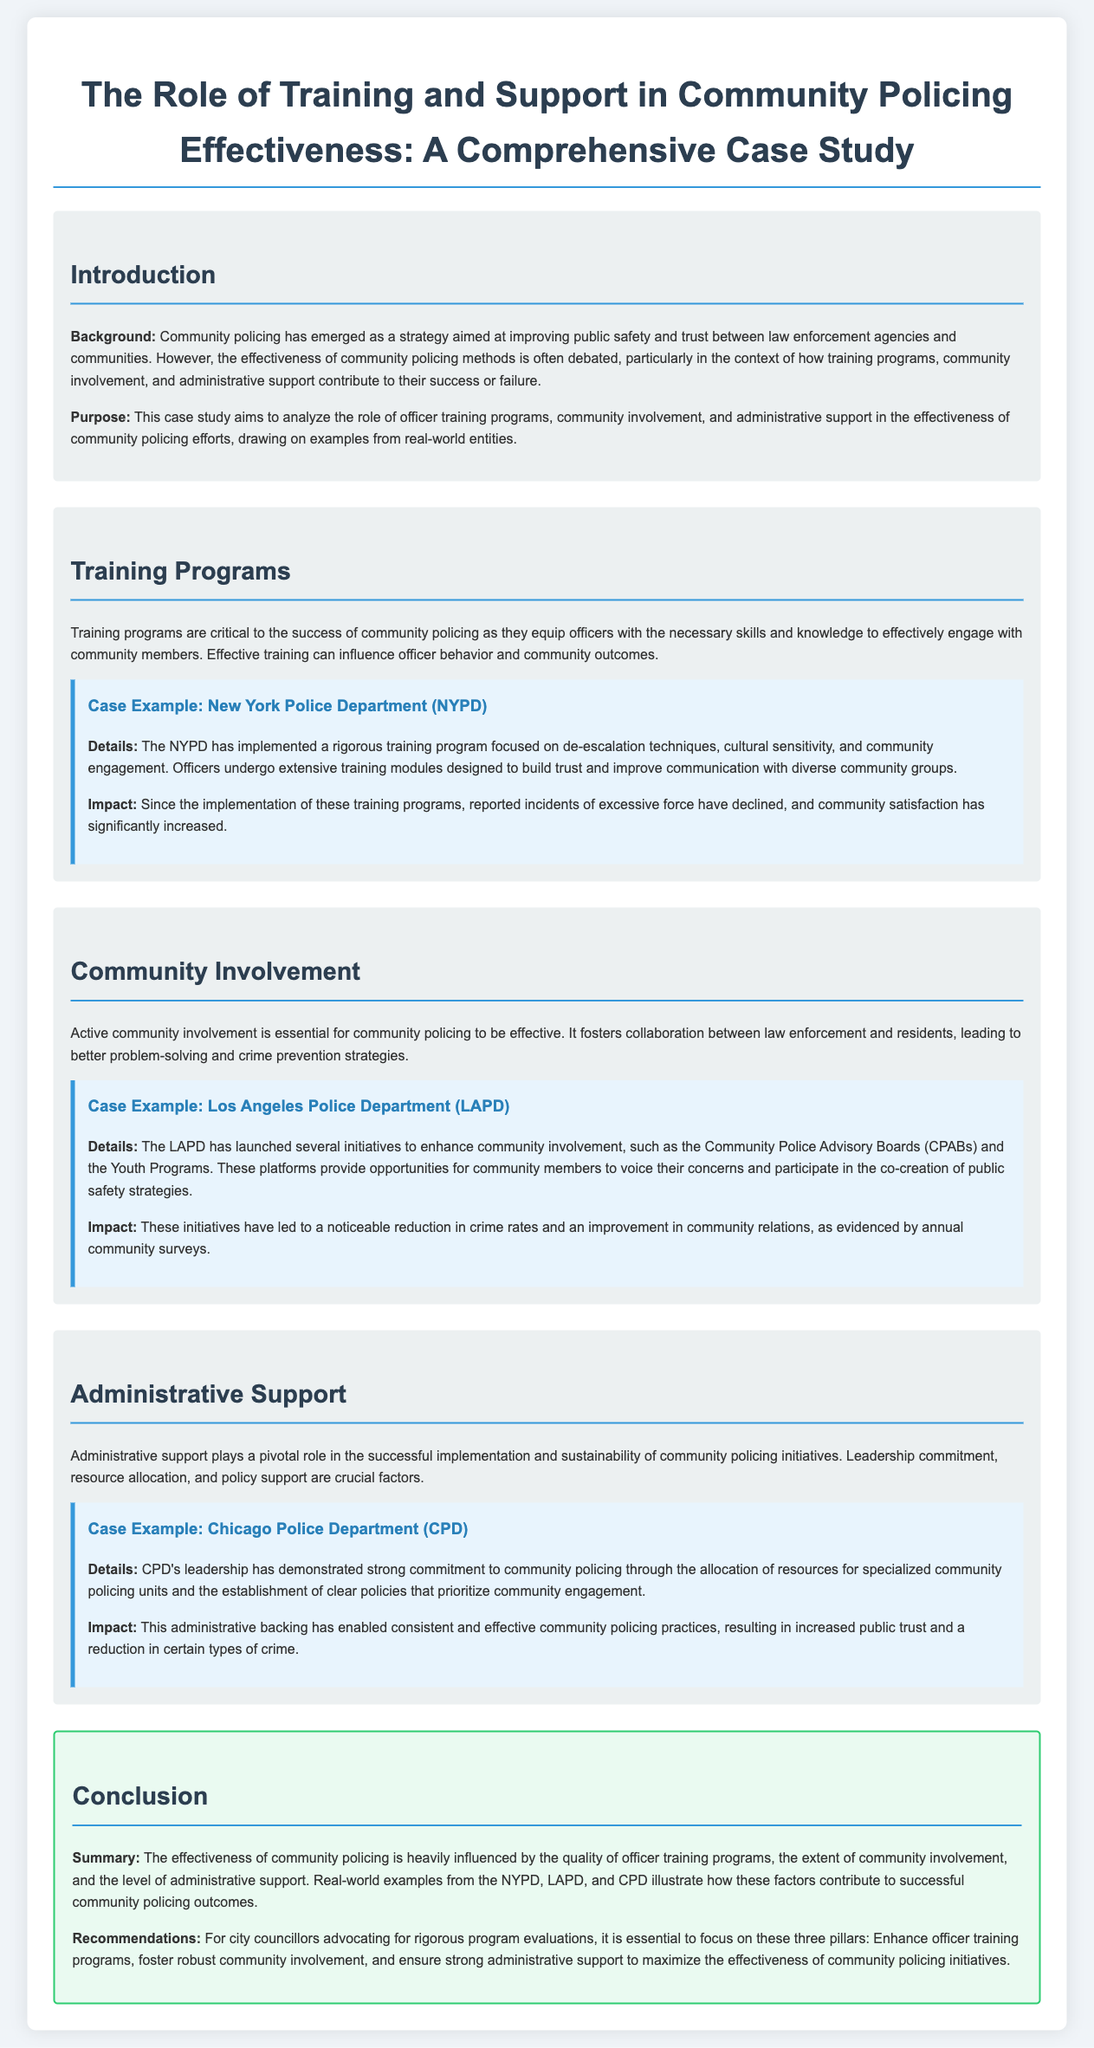what is the purpose of the case study? The purpose of the case study is to analyze the role of officer training programs, community involvement, and administrative support in the effectiveness of community policing efforts.
Answer: analyze the role of officer training programs, community involvement, and administrative support in the effectiveness of community policing efforts which department implemented training focusing on de-escalation techniques? The New York Police Department implemented training focusing on de-escalation techniques.
Answer: New York Police Department what are the initiatives launched by LAPD to enhance community involvement? The LAPD launched Community Police Advisory Boards and Youth Programs to enhance community involvement.
Answer: Community Police Advisory Boards and Youth Programs which case example highlighted the impact of administrative support? The Chicago Police Department highlighted the impact of administrative support.
Answer: Chicago Police Department what was the outcome of NYPD's training programs? The outcome of NYPD's training programs was a decline in reported incidents of excessive force and an increase in community satisfaction.
Answer: decline in reported incidents of excessive force and an increase in community satisfaction what factors are crucial for administrative support in community policing? Leadership commitment, resource allocation, and policy support are crucial factors for administrative support in community policing.
Answer: Leadership commitment, resource allocation, and policy support how does the community involvement contribute to crime prevention? Active community involvement fosters collaboration between law enforcement and residents, leading to better problem-solving and crime prevention.
Answer: fosters collaboration between law enforcement and residents what is a key recommendation from the case study? A key recommendation from the case study is to enhance officer training programs to maximize the effectiveness of community policing initiatives.
Answer: enhance officer training programs 